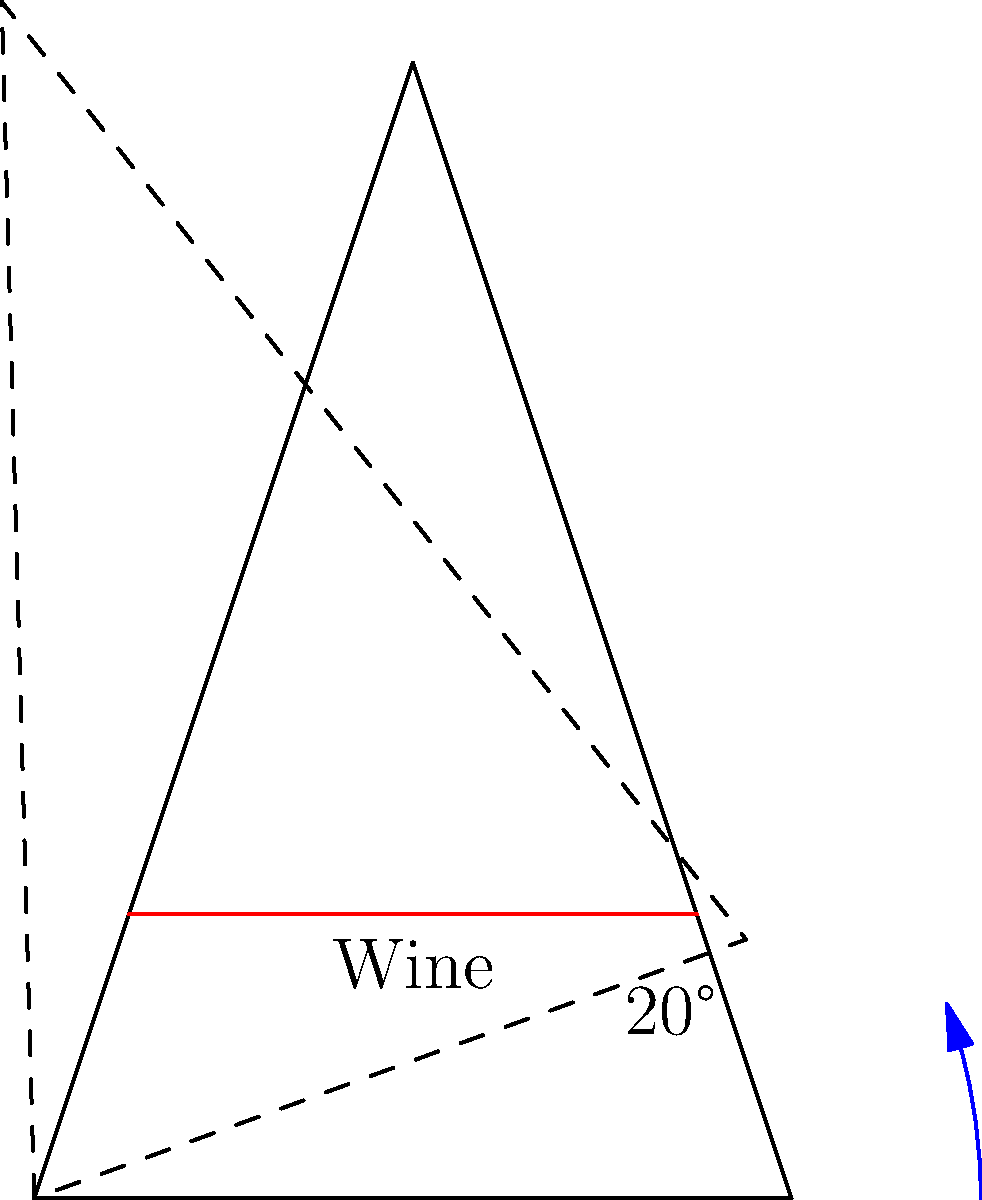As a gourmet cook hosting lively dinner parties, you want to enhance the wine-tasting experience for your guests. What is the optimal angle to tilt a wine glass to maximize the release of aromas without spilling? To determine the optimal angle for tilting a wine glass, we need to consider several factors:

1. Surface area exposure: Tilting increases the surface area of the wine exposed to air, enhancing aroma release.

2. Volatility of compounds: Wine aromas are volatile organic compounds that evaporate more readily when exposed to air.

3. Risk of spillage: Tilting too much can lead to spilling, which we want to avoid.

4. Glass shape: The typical wine glass has a bowl that narrows towards the top, which concentrates aromas.

5. Wine volume: The glass should not be overfilled to allow for proper tilting.

Research and expert sommeliers suggest the following:

- A tilt between 15° and 25° is generally considered optimal.
- At this angle range, the wine's surface area is significantly increased without risk of spillage.
- The 20° angle shown in the diagram is often cited as an ideal compromise.

This angle allows for:
a) Maximum aroma release
b) Minimal risk of spilling
c) Comfortable holding position for the taster

The exact angle may vary slightly depending on the specific glass shape and wine volume, but 20° serves as an excellent general guideline for enhancing the aromatic experience during wine tasting.
Answer: 20° 